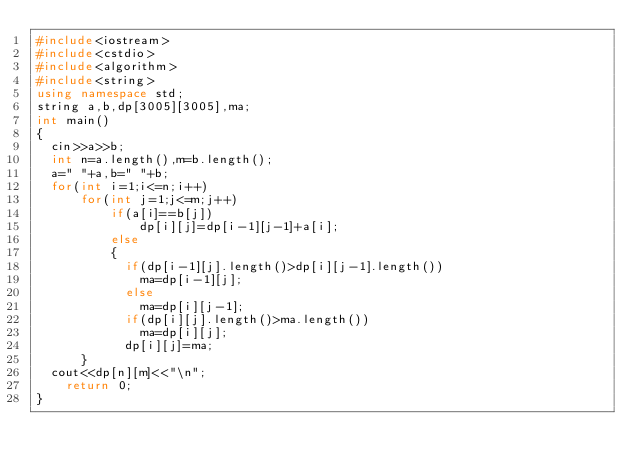<code> <loc_0><loc_0><loc_500><loc_500><_C++_>#include<iostream>
#include<cstdio>
#include<algorithm>
#include<string> 
using namespace std;
string a,b,dp[3005][3005],ma;
int main() 
{
	cin>>a>>b;
	int n=a.length(),m=b.length();
	a=" "+a,b=" "+b;
	for(int i=1;i<=n;i++)
	    for(int j=1;j<=m;j++)
	        if(a[i]==b[j])
	            dp[i][j]=dp[i-1][j-1]+a[i];
	        else
	        {
	        	if(dp[i-1][j].length()>dp[i][j-1].length())
	        		ma=dp[i-1][j];
	        	else
	        		ma=dp[i][j-1];
	        	if(dp[i][j].length()>ma.length())
	        		ma=dp[i][j];
	        	dp[i][j]=ma;
			}
	cout<<dp[n][m]<<"\n";
    return 0;
}</code> 